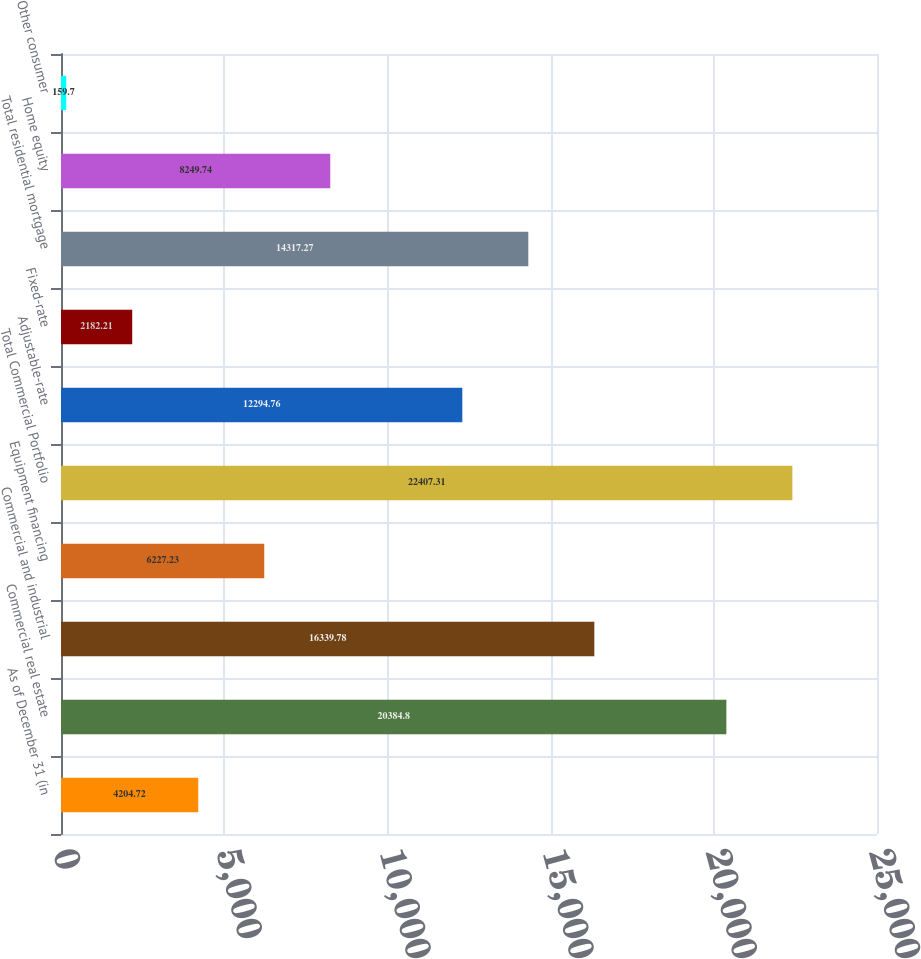<chart> <loc_0><loc_0><loc_500><loc_500><bar_chart><fcel>As of December 31 (in<fcel>Commercial real estate<fcel>Commercial and industrial<fcel>Equipment financing<fcel>Total Commercial Portfolio<fcel>Adjustable-rate<fcel>Fixed-rate<fcel>Total residential mortgage<fcel>Home equity<fcel>Other consumer<nl><fcel>4204.72<fcel>20384.8<fcel>16339.8<fcel>6227.23<fcel>22407.3<fcel>12294.8<fcel>2182.21<fcel>14317.3<fcel>8249.74<fcel>159.7<nl></chart> 